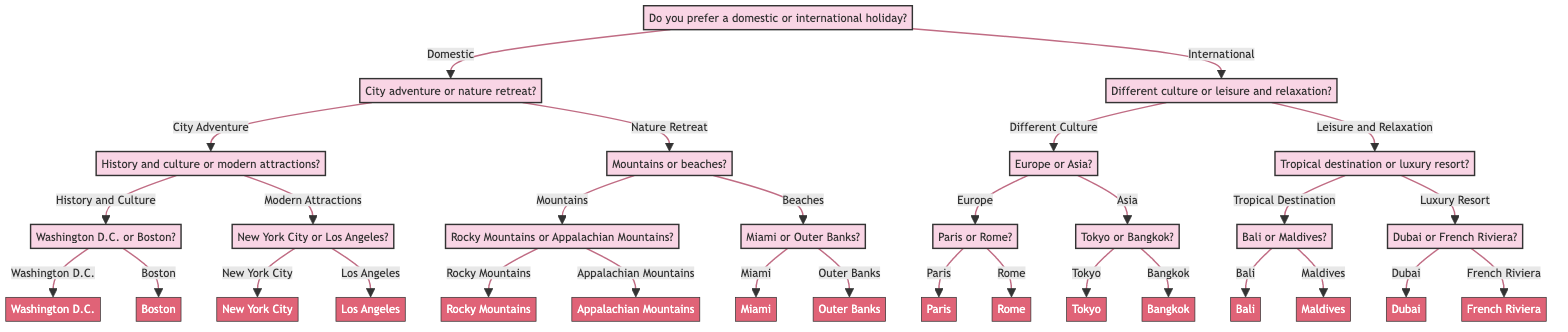What is the first question in the decision tree? The decision tree starts with the question "Do you prefer a domestic or international holiday?" at the root node.
Answer: Do you prefer a domestic or international holiday? How many main branches are there from the starting question? From the starting question, there are two branches: one for "Domestic" and another for "International." This indicates two main options for the holiday destination.
Answer: 2 If the choice is "Domestic," what are the two next options? If you choose "Domestic," the two next options are "City Adventure" and "Nature Retreat," indicating the type of experience within domestic travel.
Answer: City Adventure or Nature Retreat What follows after choosing "City Adventure"? After choosing "City Adventure," the next question is whether to prefer "History and Culture" or "Modern Attractions," allowing for a more specific choice in urban experiences.
Answer: History and Culture or Modern Attractions What would be the final destinations if we follow "International" to "Different Culture" to "Europe" and then "Paris"? Following this path leads us to "Paris," which is the final destination for those who choose this specific route through the decision tree.
Answer: Paris In how many destinations can you end up if you choose "Leisure and Relaxation"? If you choose "Leisure and Relaxation," you can end up in four different destinations: "Bali," "Maldives," "Dubai," or "French Riviera," indicating various options for relaxing vacations.
Answer: 4 What question is asked after choosing "Nature Retreat" and "Mountains"? After choosing "Nature Retreat" and then "Mountains," the next question asked is "Should we visit the Rocky Mountains or the Appalachian Mountains?" which specifies further destinations in nature retreats.
Answer: Should we visit the Rocky Mountains or the Appalachian Mountains? Which two destinations are at the end of the path for "Modern Attractions"? The end of the path for "Modern Attractions" leads to two destinations: "New York City" and "Los Angeles," indicating popular urban destinations focused on modern entertainment.
Answer: New York City or Los Angeles 